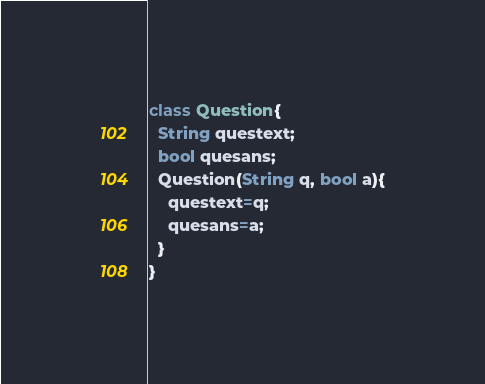Convert code to text. <code><loc_0><loc_0><loc_500><loc_500><_Dart_>class Question{
  String questext;
  bool quesans;
  Question(String q, bool a){
    questext=q;
    quesans=a;
  }
}</code> 